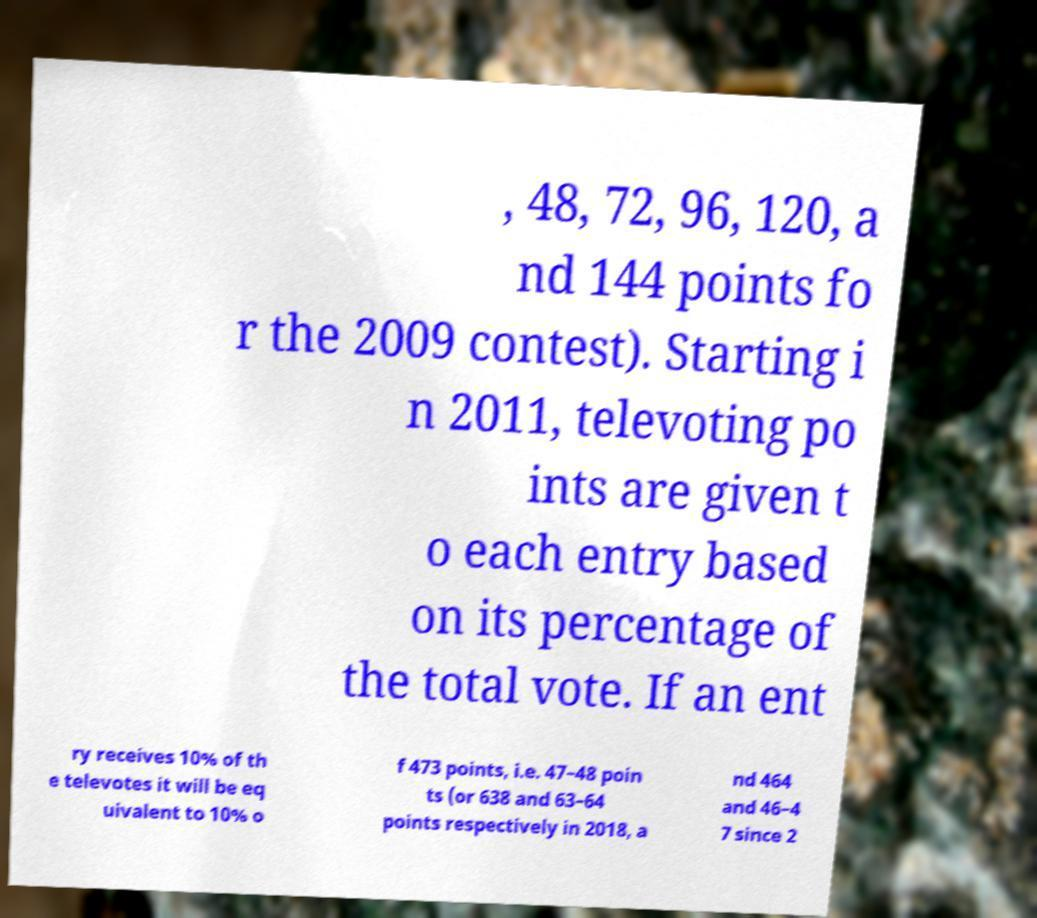Could you assist in decoding the text presented in this image and type it out clearly? , 48, 72, 96, 120, a nd 144 points fo r the 2009 contest). Starting i n 2011, televoting po ints are given t o each entry based on its percentage of the total vote. If an ent ry receives 10% of th e televotes it will be eq uivalent to 10% o f 473 points, i.e. 47–48 poin ts (or 638 and 63–64 points respectively in 2018, a nd 464 and 46–4 7 since 2 